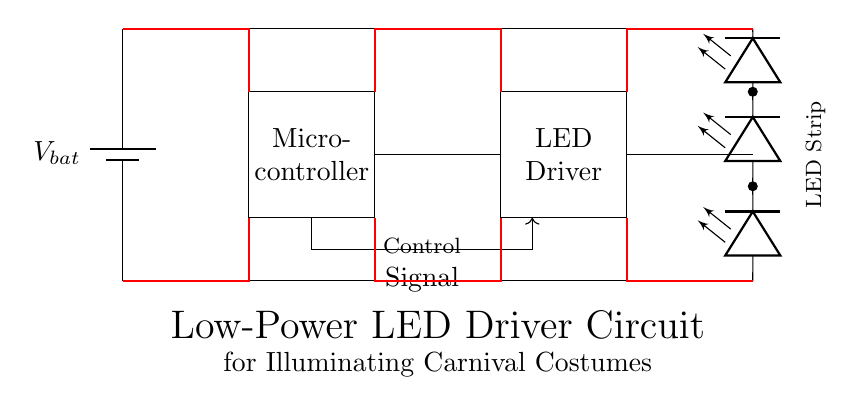What component provides power to the circuit? The battery symbol in the diagram represents the power source, which is the battery labeled as V bat.
Answer: battery What is the role of the microcontroller in this circuit? The microcontroller sends control signals to the LED driver, managing their operation such as turning them on and off or regulating their brightness.
Answer: control signals How many LEDs are depicted in the circuit? There are four LED symbols shown in the diagram indicating the number of LEDs that can be controlled by the LED driver.
Answer: four What is the connection between the microcontroller and LED driver? The microcontroller is connected to the LED driver via a control signal wire, which allows for communication between the two components.
Answer: control signal What type of circuit is this primarily designed for? The circuit is designed primarily for low-power applications specifically focused on illuminating carnival costumes using LED lights.
Answer: low-power LED driver circuit What voltage does the circuit likely operate at? While the specific voltage is not indicated, typical battery voltages for such circuits are around 3V to 5V, based on common battery specifications.
Answer: 5V What is the purpose of the red thick lines in the circuit? The red thick lines represent the power paths in the circuit, indicating where power flows from the battery to the other components such as the microcontroller and LED driver.
Answer: power paths 